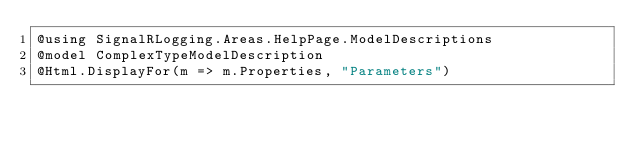Convert code to text. <code><loc_0><loc_0><loc_500><loc_500><_C#_>@using SignalRLogging.Areas.HelpPage.ModelDescriptions
@model ComplexTypeModelDescription
@Html.DisplayFor(m => m.Properties, "Parameters")</code> 